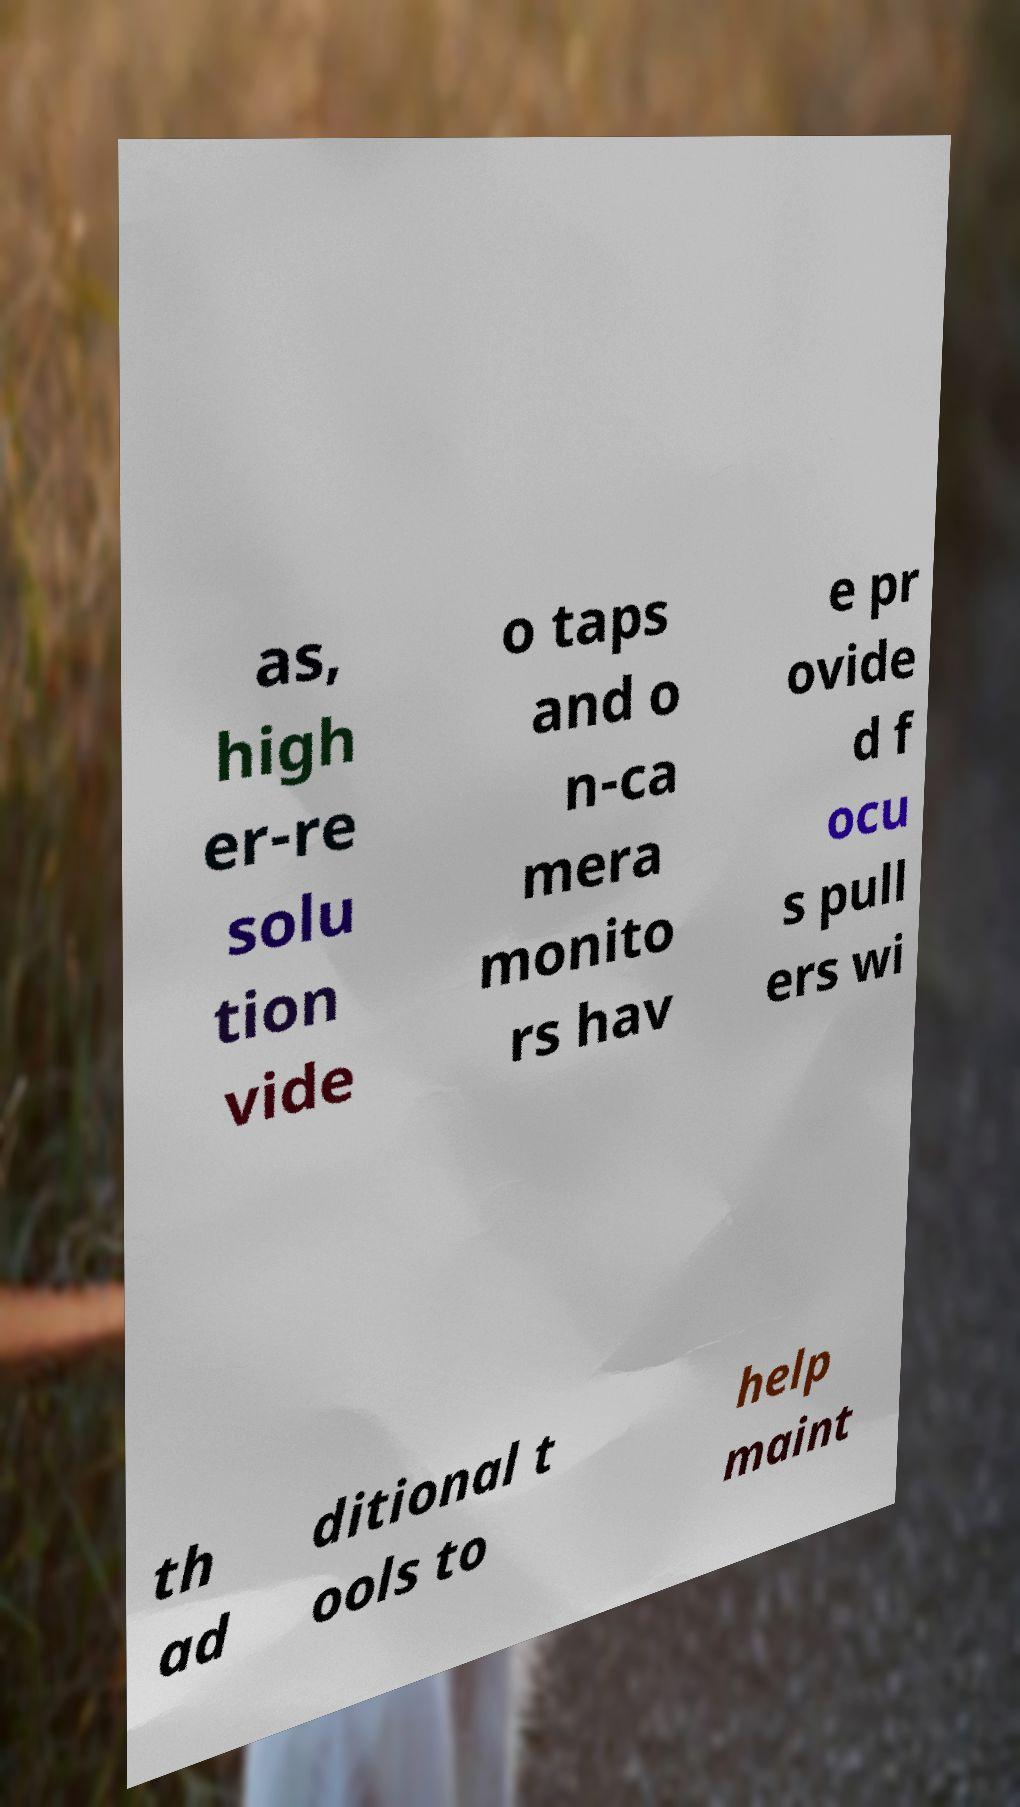Please identify and transcribe the text found in this image. as, high er-re solu tion vide o taps and o n-ca mera monito rs hav e pr ovide d f ocu s pull ers wi th ad ditional t ools to help maint 